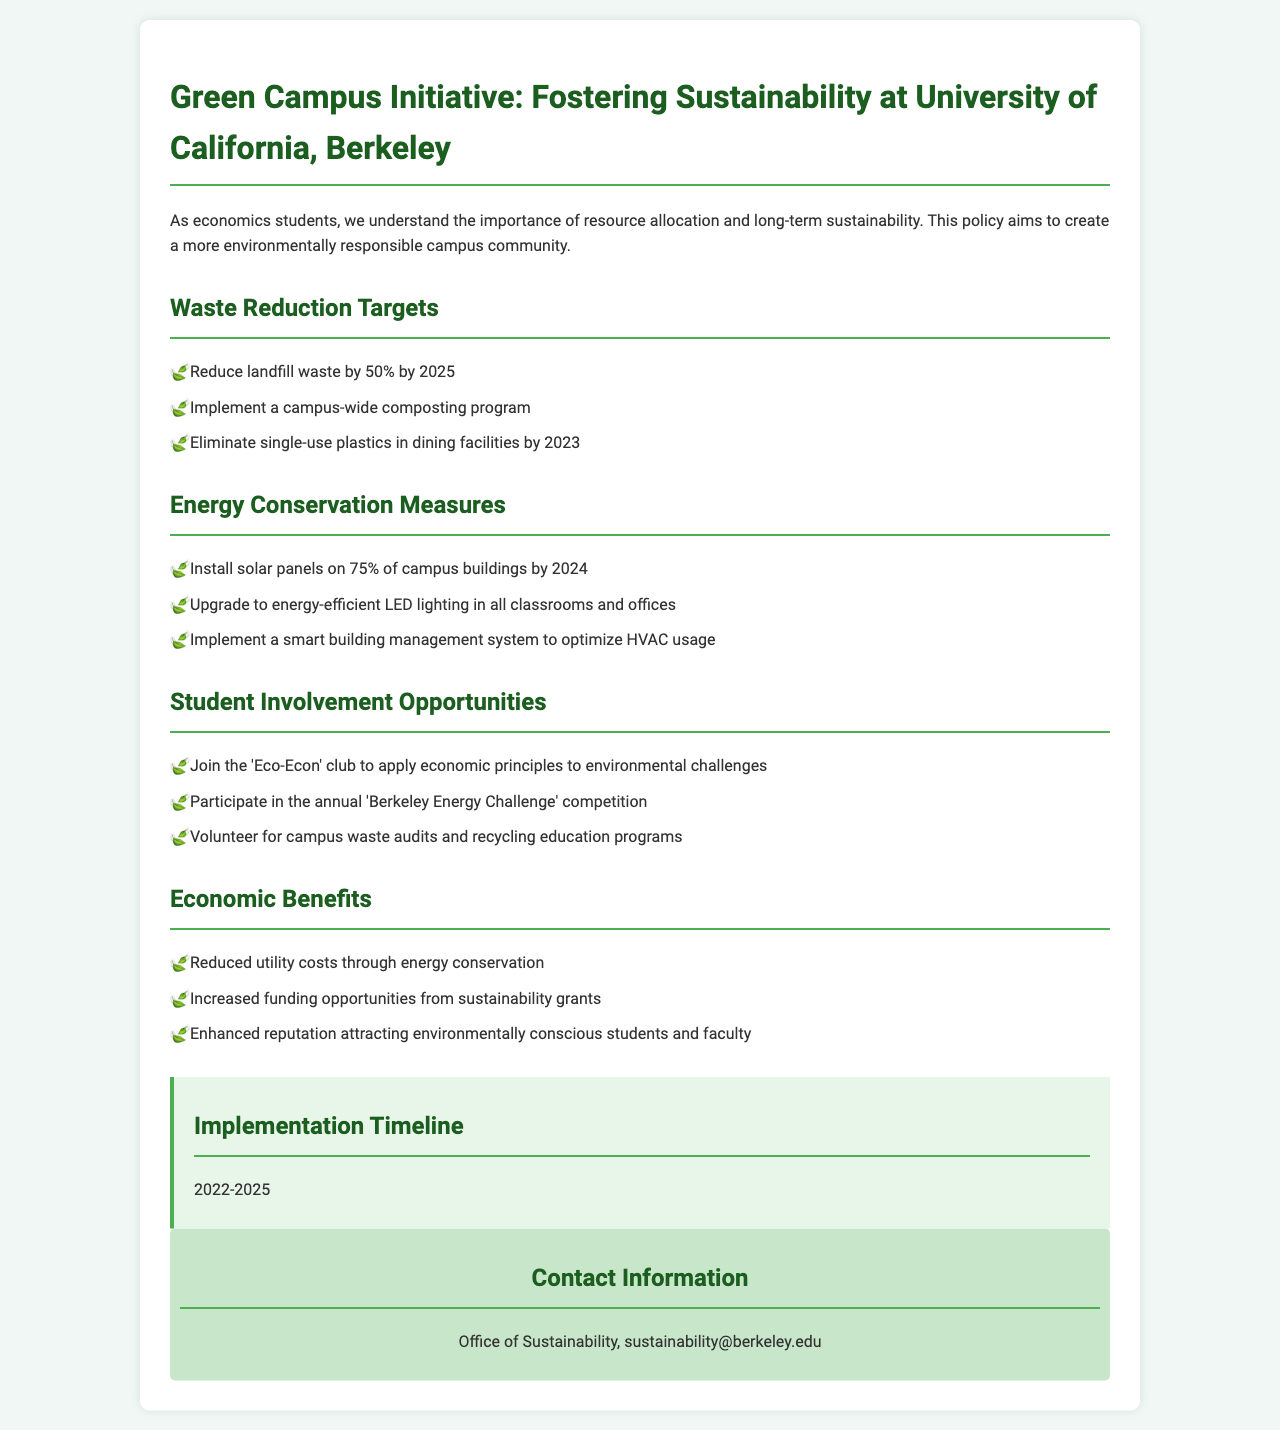What is the waste reduction target for landfill waste? The document states the target is to reduce landfill waste by 50% by 2025.
Answer: 50% What year should single-use plastics be eliminated in dining facilities? The document indicates that single-use plastics should be eliminated by 2023.
Answer: 2023 What percentage of campus buildings will have solar panels installed by 2024? The document mentions that solar panels will be installed on 75% of campus buildings by 2024.
Answer: 75% What competition can students participate in to engage with energy conservation? The document lists the 'Berkeley Energy Challenge' competition as an opportunity for student involvement.
Answer: Berkeley Energy Challenge What is one economic benefit mentioned in the policy? The document highlights reduced utility costs through energy conservation as one economic benefit.
Answer: Reduced utility costs What is the overall implementation timeline for the initiative? The document specifies that the implementation timeline is from 2022 to 2025.
Answer: 2022-2025 Which club can students join to apply economic principles to environmental challenges? The document mentions the 'Eco-Econ' club as an opportunity for students.
Answer: Eco-Econ How can students volunteer according to the policy document? The document lists volunteering for campus waste audits and recycling education programs as a way for students to get involved.
Answer: Campus waste audits and recycling education programs 